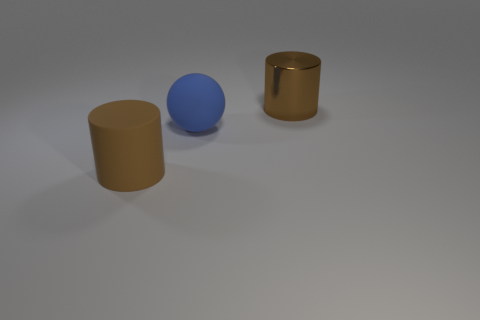The big thing that is both behind the big brown matte cylinder and in front of the brown metallic cylinder is what color?
Your answer should be very brief. Blue. There is a brown cylinder behind the big blue sphere; is there a big ball in front of it?
Keep it short and to the point. Yes. Are there any big blue objects behind the brown matte thing?
Keep it short and to the point. Yes. Are there an equal number of big matte things that are on the right side of the large matte cylinder and blue rubber balls right of the matte ball?
Keep it short and to the point. No. What number of yellow cubes are there?
Your response must be concise. 0. Are there more large rubber balls behind the brown matte object than red matte cubes?
Provide a succinct answer. Yes. There is a brown object that is on the left side of the big metal cylinder; what is its material?
Your answer should be compact. Rubber. There is a matte object that is the same shape as the shiny object; what is its color?
Ensure brevity in your answer.  Brown. How many large matte objects have the same color as the big shiny thing?
Provide a succinct answer. 1. There is a shiny object that is behind the large blue ball; is its size the same as the blue ball that is on the left side of the brown metallic object?
Give a very brief answer. Yes. 